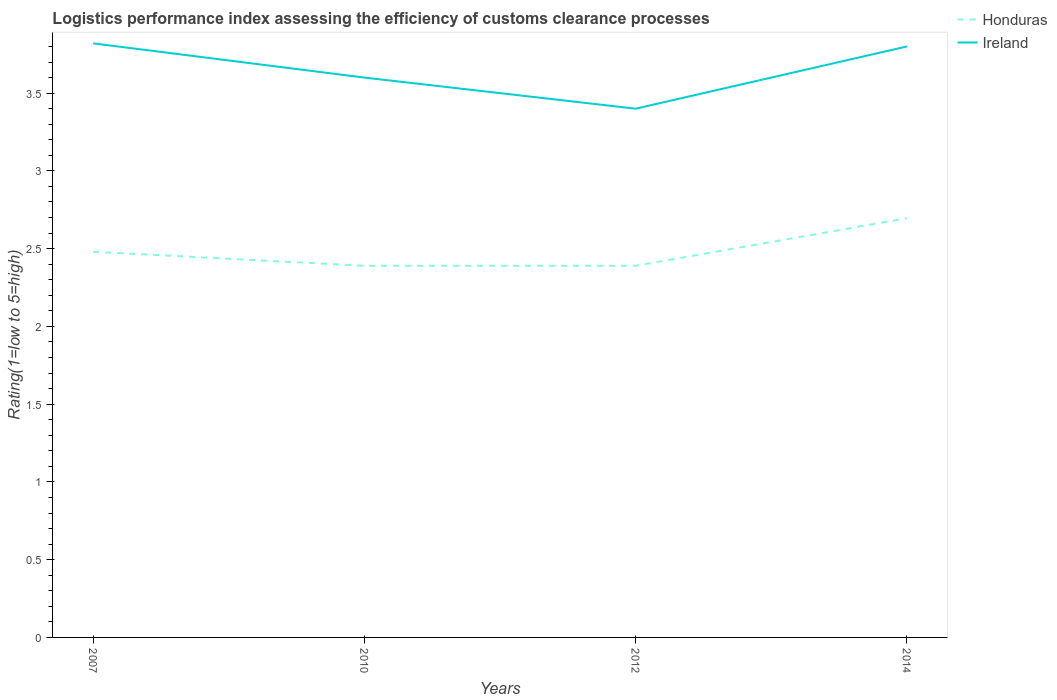Does the line corresponding to Honduras intersect with the line corresponding to Ireland?
Your answer should be compact. No. Across all years, what is the maximum Logistic performance index in Honduras?
Give a very brief answer. 2.39. What is the total Logistic performance index in Ireland in the graph?
Offer a terse response. -0.4. What is the difference between the highest and the second highest Logistic performance index in Honduras?
Offer a very short reply. 0.31. How many lines are there?
Give a very brief answer. 2. How many years are there in the graph?
Keep it short and to the point. 4. Are the values on the major ticks of Y-axis written in scientific E-notation?
Keep it short and to the point. No. Does the graph contain grids?
Offer a very short reply. No. How are the legend labels stacked?
Ensure brevity in your answer.  Vertical. What is the title of the graph?
Provide a succinct answer. Logistics performance index assessing the efficiency of customs clearance processes. Does "Maldives" appear as one of the legend labels in the graph?
Offer a terse response. No. What is the label or title of the Y-axis?
Keep it short and to the point. Rating(1=low to 5=high). What is the Rating(1=low to 5=high) in Honduras in 2007?
Your answer should be very brief. 2.48. What is the Rating(1=low to 5=high) of Ireland in 2007?
Your response must be concise. 3.82. What is the Rating(1=low to 5=high) of Honduras in 2010?
Ensure brevity in your answer.  2.39. What is the Rating(1=low to 5=high) in Honduras in 2012?
Offer a terse response. 2.39. What is the Rating(1=low to 5=high) of Ireland in 2012?
Keep it short and to the point. 3.4. What is the Rating(1=low to 5=high) of Honduras in 2014?
Give a very brief answer. 2.7. What is the Rating(1=low to 5=high) of Ireland in 2014?
Your response must be concise. 3.8. Across all years, what is the maximum Rating(1=low to 5=high) in Honduras?
Your answer should be very brief. 2.7. Across all years, what is the maximum Rating(1=low to 5=high) in Ireland?
Your answer should be very brief. 3.82. Across all years, what is the minimum Rating(1=low to 5=high) in Honduras?
Keep it short and to the point. 2.39. What is the total Rating(1=low to 5=high) of Honduras in the graph?
Your response must be concise. 9.96. What is the total Rating(1=low to 5=high) of Ireland in the graph?
Offer a terse response. 14.62. What is the difference between the Rating(1=low to 5=high) of Honduras in 2007 and that in 2010?
Your response must be concise. 0.09. What is the difference between the Rating(1=low to 5=high) of Ireland in 2007 and that in 2010?
Make the answer very short. 0.22. What is the difference between the Rating(1=low to 5=high) of Honduras in 2007 and that in 2012?
Offer a terse response. 0.09. What is the difference between the Rating(1=low to 5=high) in Ireland in 2007 and that in 2012?
Ensure brevity in your answer.  0.42. What is the difference between the Rating(1=low to 5=high) of Honduras in 2007 and that in 2014?
Keep it short and to the point. -0.22. What is the difference between the Rating(1=low to 5=high) in Honduras in 2010 and that in 2012?
Ensure brevity in your answer.  0. What is the difference between the Rating(1=low to 5=high) of Ireland in 2010 and that in 2012?
Make the answer very short. 0.2. What is the difference between the Rating(1=low to 5=high) of Honduras in 2010 and that in 2014?
Your answer should be very brief. -0.31. What is the difference between the Rating(1=low to 5=high) in Ireland in 2010 and that in 2014?
Offer a terse response. -0.2. What is the difference between the Rating(1=low to 5=high) of Honduras in 2012 and that in 2014?
Provide a short and direct response. -0.31. What is the difference between the Rating(1=low to 5=high) in Honduras in 2007 and the Rating(1=low to 5=high) in Ireland in 2010?
Keep it short and to the point. -1.12. What is the difference between the Rating(1=low to 5=high) of Honduras in 2007 and the Rating(1=low to 5=high) of Ireland in 2012?
Ensure brevity in your answer.  -0.92. What is the difference between the Rating(1=low to 5=high) of Honduras in 2007 and the Rating(1=low to 5=high) of Ireland in 2014?
Give a very brief answer. -1.32. What is the difference between the Rating(1=low to 5=high) in Honduras in 2010 and the Rating(1=low to 5=high) in Ireland in 2012?
Your answer should be compact. -1.01. What is the difference between the Rating(1=low to 5=high) in Honduras in 2010 and the Rating(1=low to 5=high) in Ireland in 2014?
Offer a terse response. -1.41. What is the difference between the Rating(1=low to 5=high) in Honduras in 2012 and the Rating(1=low to 5=high) in Ireland in 2014?
Your answer should be very brief. -1.41. What is the average Rating(1=low to 5=high) in Honduras per year?
Make the answer very short. 2.49. What is the average Rating(1=low to 5=high) in Ireland per year?
Make the answer very short. 3.65. In the year 2007, what is the difference between the Rating(1=low to 5=high) in Honduras and Rating(1=low to 5=high) in Ireland?
Keep it short and to the point. -1.34. In the year 2010, what is the difference between the Rating(1=low to 5=high) of Honduras and Rating(1=low to 5=high) of Ireland?
Make the answer very short. -1.21. In the year 2012, what is the difference between the Rating(1=low to 5=high) in Honduras and Rating(1=low to 5=high) in Ireland?
Give a very brief answer. -1.01. In the year 2014, what is the difference between the Rating(1=low to 5=high) in Honduras and Rating(1=low to 5=high) in Ireland?
Your answer should be very brief. -1.1. What is the ratio of the Rating(1=low to 5=high) of Honduras in 2007 to that in 2010?
Ensure brevity in your answer.  1.04. What is the ratio of the Rating(1=low to 5=high) in Ireland in 2007 to that in 2010?
Offer a terse response. 1.06. What is the ratio of the Rating(1=low to 5=high) in Honduras in 2007 to that in 2012?
Your response must be concise. 1.04. What is the ratio of the Rating(1=low to 5=high) in Ireland in 2007 to that in 2012?
Offer a very short reply. 1.12. What is the ratio of the Rating(1=low to 5=high) of Honduras in 2007 to that in 2014?
Ensure brevity in your answer.  0.92. What is the ratio of the Rating(1=low to 5=high) in Ireland in 2007 to that in 2014?
Give a very brief answer. 1.01. What is the ratio of the Rating(1=low to 5=high) of Honduras in 2010 to that in 2012?
Your answer should be very brief. 1. What is the ratio of the Rating(1=low to 5=high) in Ireland in 2010 to that in 2012?
Make the answer very short. 1.06. What is the ratio of the Rating(1=low to 5=high) in Honduras in 2010 to that in 2014?
Ensure brevity in your answer.  0.89. What is the ratio of the Rating(1=low to 5=high) of Ireland in 2010 to that in 2014?
Your answer should be very brief. 0.95. What is the ratio of the Rating(1=low to 5=high) in Honduras in 2012 to that in 2014?
Your answer should be compact. 0.89. What is the ratio of the Rating(1=low to 5=high) of Ireland in 2012 to that in 2014?
Your answer should be very brief. 0.89. What is the difference between the highest and the second highest Rating(1=low to 5=high) in Honduras?
Your answer should be compact. 0.22. What is the difference between the highest and the second highest Rating(1=low to 5=high) of Ireland?
Your answer should be very brief. 0.02. What is the difference between the highest and the lowest Rating(1=low to 5=high) of Honduras?
Give a very brief answer. 0.31. What is the difference between the highest and the lowest Rating(1=low to 5=high) of Ireland?
Your response must be concise. 0.42. 